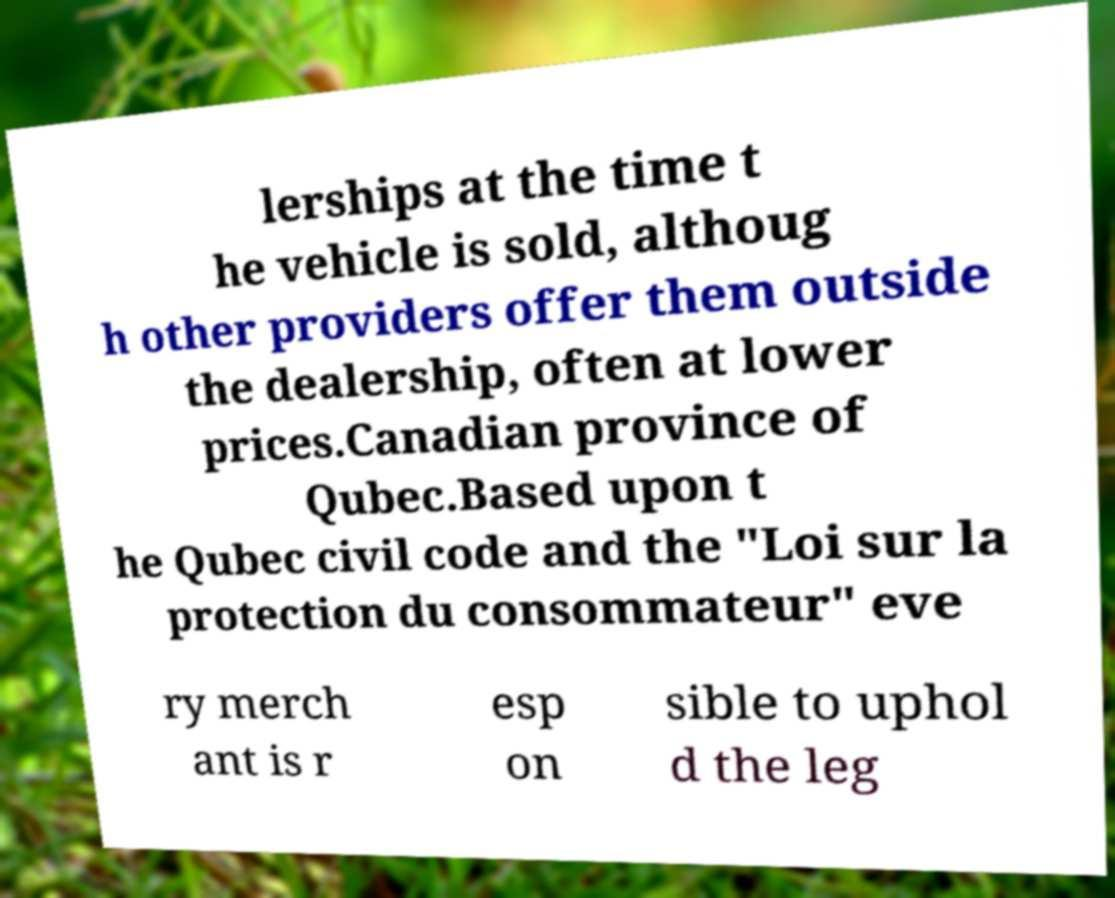For documentation purposes, I need the text within this image transcribed. Could you provide that? lerships at the time t he vehicle is sold, althoug h other providers offer them outside the dealership, often at lower prices.Canadian province of Qubec.Based upon t he Qubec civil code and the "Loi sur la protection du consommateur" eve ry merch ant is r esp on sible to uphol d the leg 